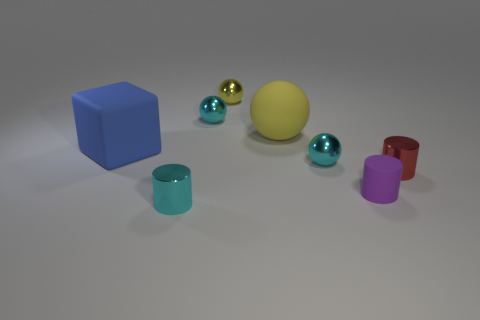Add 1 small purple rubber cylinders. How many objects exist? 9 Subtract all blocks. How many objects are left? 7 Add 5 yellow shiny spheres. How many yellow shiny spheres are left? 6 Add 3 tiny blue rubber cubes. How many tiny blue rubber cubes exist? 3 Subtract 0 red balls. How many objects are left? 8 Subtract all red shiny objects. Subtract all large green metal cylinders. How many objects are left? 7 